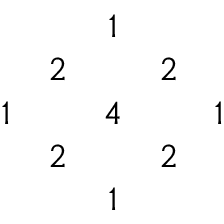Convert formula to latex. <formula><loc_0><loc_0><loc_500><loc_500>\begin{array} { c c c c c & { 1 } & { 2 } & { 2 } \\ { 1 } & { 4 } & { 1 } & { 2 } & { 2 } & { 1 } \end{array}</formula> 